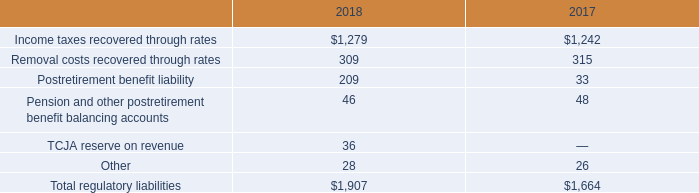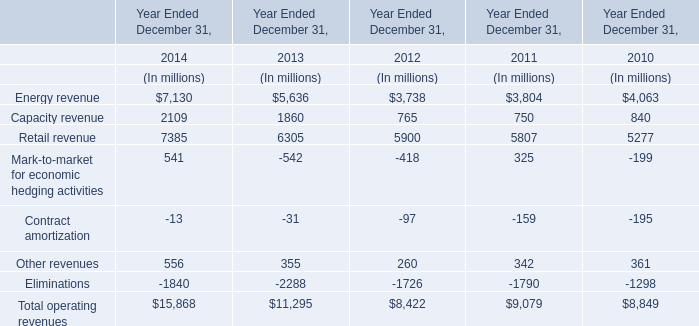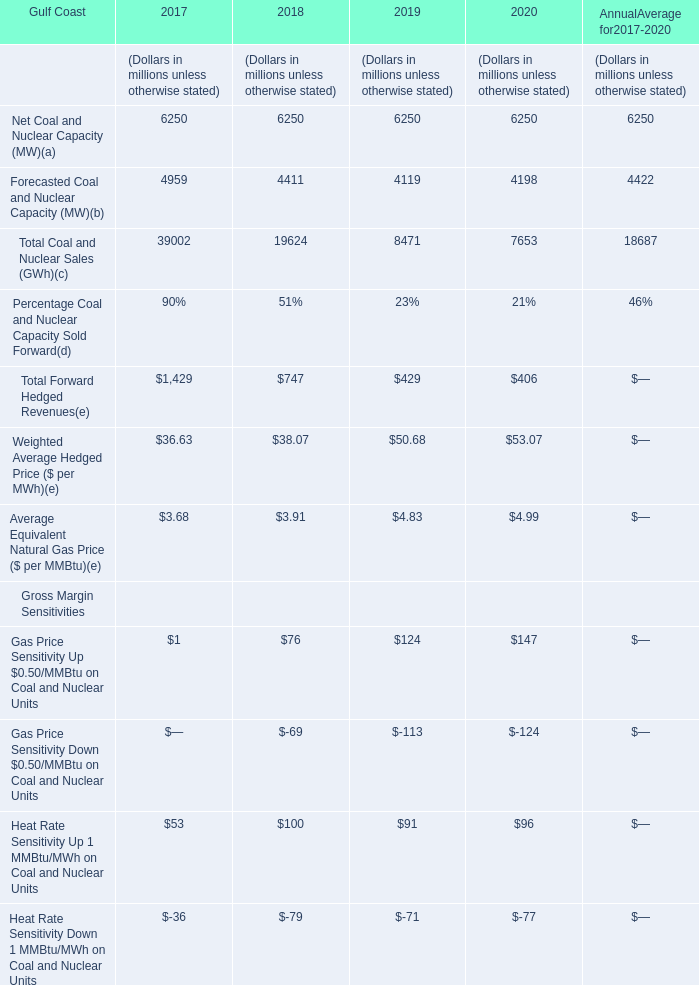Does the value of Forecasted Coal and Nuclear Capacity in 2018 greater than that in 2017? 
Answer: no. 